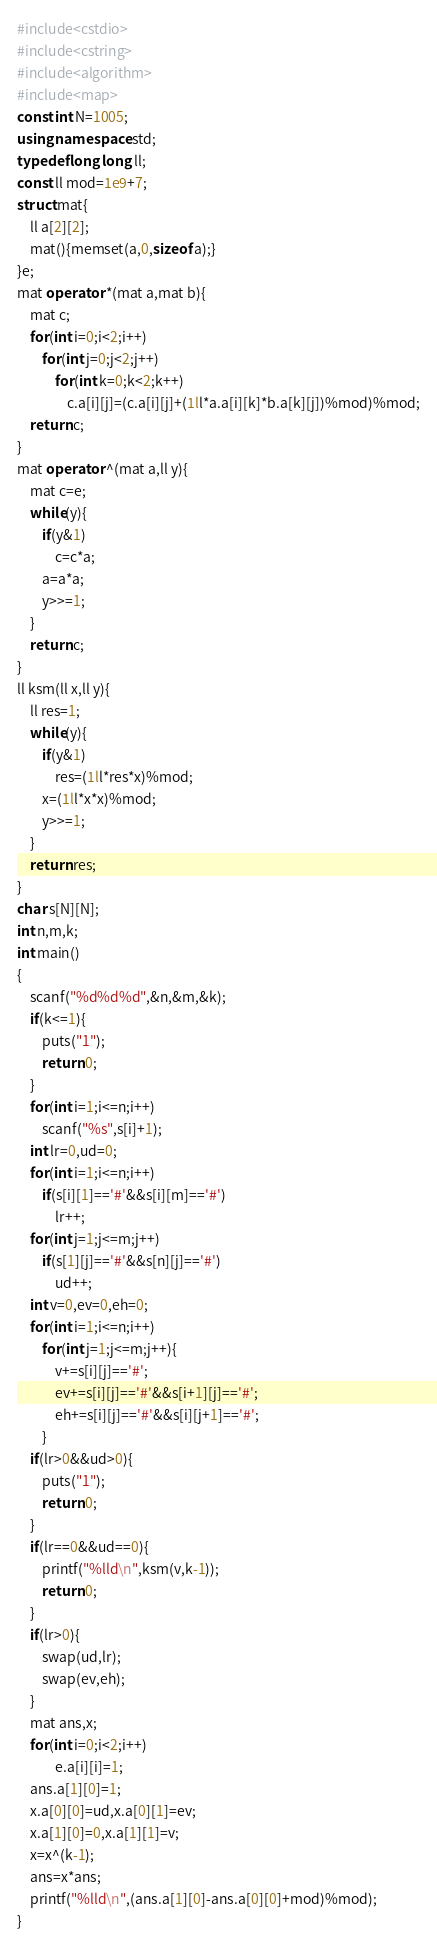Convert code to text. <code><loc_0><loc_0><loc_500><loc_500><_C++_>#include<cstdio>
#include<cstring>
#include<algorithm>
#include<map>
const int N=1005;
using namespace std;
typedef long long ll;
const ll mod=1e9+7;
struct mat{
    ll a[2][2];
    mat(){memset(a,0,sizeof a);}
}e;
mat operator *(mat a,mat b){
    mat c;
    for(int i=0;i<2;i++)
        for(int j=0;j<2;j++)
            for(int k=0;k<2;k++)
                c.a[i][j]=(c.a[i][j]+(1ll*a.a[i][k]*b.a[k][j])%mod)%mod;
    return c;
}
mat operator ^(mat a,ll y){
    mat c=e;
    while(y){
        if(y&1)
            c=c*a;
        a=a*a;
        y>>=1;
    }
    return c;
}
ll ksm(ll x,ll y){
    ll res=1;
    while(y){
        if(y&1)
            res=(1ll*res*x)%mod;
        x=(1ll*x*x)%mod;
        y>>=1;
    }
    return res;
}
char s[N][N];
int n,m,k;
int main()
{
    scanf("%d%d%d",&n,&m,&k);
    if(k<=1){
        puts("1");
        return 0;
    }
    for(int i=1;i<=n;i++)
        scanf("%s",s[i]+1);
    int lr=0,ud=0;
    for(int i=1;i<=n;i++)
        if(s[i][1]=='#'&&s[i][m]=='#')
            lr++;
    for(int j=1;j<=m;j++)
        if(s[1][j]=='#'&&s[n][j]=='#')
            ud++;
    int v=0,ev=0,eh=0;
    for(int i=1;i<=n;i++)
        for(int j=1;j<=m;j++){
            v+=s[i][j]=='#';
            ev+=s[i][j]=='#'&&s[i+1][j]=='#';
            eh+=s[i][j]=='#'&&s[i][j+1]=='#';
        }
    if(lr>0&&ud>0){
        puts("1");
        return 0;
    }
    if(lr==0&&ud==0){
        printf("%lld\n",ksm(v,k-1));
        return 0;
    }
    if(lr>0){
        swap(ud,lr);
        swap(ev,eh);
    }
    mat ans,x;
    for(int i=0;i<2;i++)
            e.a[i][i]=1;
    ans.a[1][0]=1;
    x.a[0][0]=ud,x.a[0][1]=ev;
    x.a[1][0]=0,x.a[1][1]=v;
    x=x^(k-1);
    ans=x*ans;
    printf("%lld\n",(ans.a[1][0]-ans.a[0][0]+mod)%mod);
}
</code> 